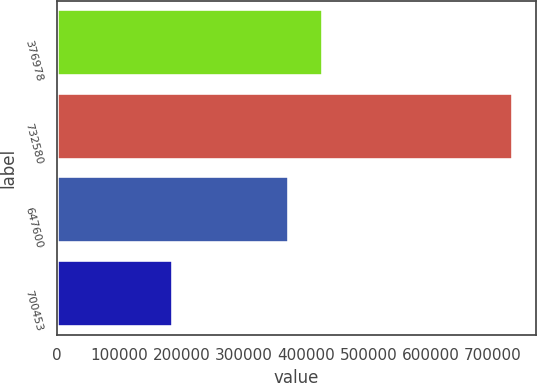<chart> <loc_0><loc_0><loc_500><loc_500><bar_chart><fcel>376978<fcel>732580<fcel>647600<fcel>700453<nl><fcel>427516<fcel>732580<fcel>372840<fcel>185825<nl></chart> 